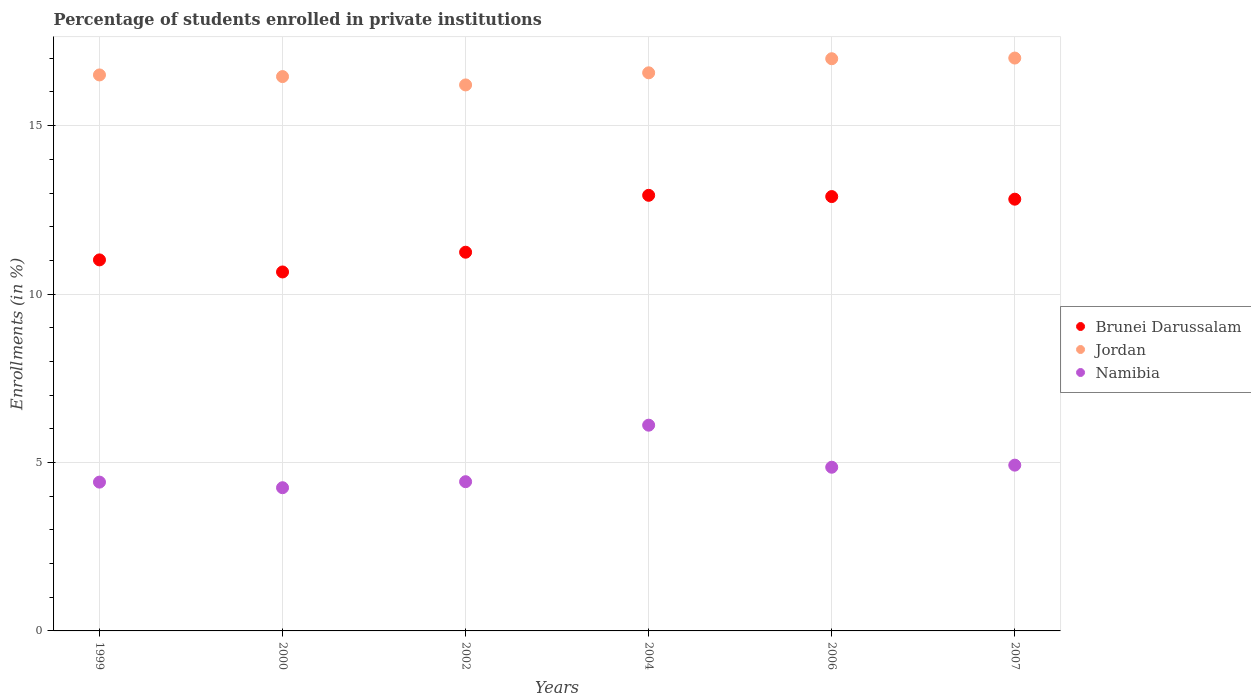How many different coloured dotlines are there?
Your answer should be compact. 3. Is the number of dotlines equal to the number of legend labels?
Ensure brevity in your answer.  Yes. What is the percentage of trained teachers in Jordan in 2004?
Offer a very short reply. 16.57. Across all years, what is the maximum percentage of trained teachers in Jordan?
Provide a succinct answer. 17.01. Across all years, what is the minimum percentage of trained teachers in Namibia?
Your response must be concise. 4.25. In which year was the percentage of trained teachers in Namibia maximum?
Your response must be concise. 2004. In which year was the percentage of trained teachers in Namibia minimum?
Keep it short and to the point. 2000. What is the total percentage of trained teachers in Jordan in the graph?
Offer a terse response. 99.73. What is the difference between the percentage of trained teachers in Jordan in 2000 and that in 2007?
Keep it short and to the point. -0.55. What is the difference between the percentage of trained teachers in Brunei Darussalam in 2004 and the percentage of trained teachers in Jordan in 2002?
Keep it short and to the point. -3.28. What is the average percentage of trained teachers in Namibia per year?
Make the answer very short. 4.83. In the year 2000, what is the difference between the percentage of trained teachers in Brunei Darussalam and percentage of trained teachers in Jordan?
Offer a very short reply. -5.8. What is the ratio of the percentage of trained teachers in Brunei Darussalam in 2006 to that in 2007?
Offer a terse response. 1.01. Is the difference between the percentage of trained teachers in Brunei Darussalam in 2002 and 2004 greater than the difference between the percentage of trained teachers in Jordan in 2002 and 2004?
Provide a succinct answer. No. What is the difference between the highest and the second highest percentage of trained teachers in Brunei Darussalam?
Your answer should be very brief. 0.04. What is the difference between the highest and the lowest percentage of trained teachers in Brunei Darussalam?
Provide a short and direct response. 2.28. In how many years, is the percentage of trained teachers in Jordan greater than the average percentage of trained teachers in Jordan taken over all years?
Ensure brevity in your answer.  2. Is it the case that in every year, the sum of the percentage of trained teachers in Namibia and percentage of trained teachers in Brunei Darussalam  is greater than the percentage of trained teachers in Jordan?
Keep it short and to the point. No. Does the percentage of trained teachers in Jordan monotonically increase over the years?
Offer a very short reply. No. Is the percentage of trained teachers in Brunei Darussalam strictly greater than the percentage of trained teachers in Namibia over the years?
Provide a succinct answer. Yes. Is the percentage of trained teachers in Jordan strictly less than the percentage of trained teachers in Brunei Darussalam over the years?
Offer a terse response. No. How many years are there in the graph?
Keep it short and to the point. 6. Are the values on the major ticks of Y-axis written in scientific E-notation?
Offer a very short reply. No. Does the graph contain any zero values?
Provide a succinct answer. No. How are the legend labels stacked?
Offer a terse response. Vertical. What is the title of the graph?
Offer a very short reply. Percentage of students enrolled in private institutions. What is the label or title of the X-axis?
Make the answer very short. Years. What is the label or title of the Y-axis?
Keep it short and to the point. Enrollments (in %). What is the Enrollments (in %) in Brunei Darussalam in 1999?
Your answer should be compact. 11.01. What is the Enrollments (in %) in Jordan in 1999?
Offer a terse response. 16.51. What is the Enrollments (in %) in Namibia in 1999?
Give a very brief answer. 4.42. What is the Enrollments (in %) of Brunei Darussalam in 2000?
Your response must be concise. 10.66. What is the Enrollments (in %) in Jordan in 2000?
Offer a very short reply. 16.46. What is the Enrollments (in %) in Namibia in 2000?
Ensure brevity in your answer.  4.25. What is the Enrollments (in %) of Brunei Darussalam in 2002?
Offer a terse response. 11.24. What is the Enrollments (in %) of Jordan in 2002?
Make the answer very short. 16.21. What is the Enrollments (in %) in Namibia in 2002?
Offer a very short reply. 4.43. What is the Enrollments (in %) in Brunei Darussalam in 2004?
Keep it short and to the point. 12.93. What is the Enrollments (in %) of Jordan in 2004?
Provide a short and direct response. 16.57. What is the Enrollments (in %) of Namibia in 2004?
Offer a very short reply. 6.11. What is the Enrollments (in %) in Brunei Darussalam in 2006?
Offer a very short reply. 12.89. What is the Enrollments (in %) of Jordan in 2006?
Provide a short and direct response. 16.99. What is the Enrollments (in %) of Namibia in 2006?
Provide a short and direct response. 4.86. What is the Enrollments (in %) in Brunei Darussalam in 2007?
Your response must be concise. 12.82. What is the Enrollments (in %) of Jordan in 2007?
Make the answer very short. 17.01. What is the Enrollments (in %) in Namibia in 2007?
Offer a terse response. 4.92. Across all years, what is the maximum Enrollments (in %) in Brunei Darussalam?
Offer a very short reply. 12.93. Across all years, what is the maximum Enrollments (in %) of Jordan?
Offer a very short reply. 17.01. Across all years, what is the maximum Enrollments (in %) in Namibia?
Keep it short and to the point. 6.11. Across all years, what is the minimum Enrollments (in %) in Brunei Darussalam?
Offer a very short reply. 10.66. Across all years, what is the minimum Enrollments (in %) of Jordan?
Your answer should be compact. 16.21. Across all years, what is the minimum Enrollments (in %) in Namibia?
Offer a terse response. 4.25. What is the total Enrollments (in %) of Brunei Darussalam in the graph?
Provide a short and direct response. 71.56. What is the total Enrollments (in %) of Jordan in the graph?
Provide a succinct answer. 99.73. What is the total Enrollments (in %) of Namibia in the graph?
Make the answer very short. 28.99. What is the difference between the Enrollments (in %) of Brunei Darussalam in 1999 and that in 2000?
Your answer should be compact. 0.36. What is the difference between the Enrollments (in %) in Jordan in 1999 and that in 2000?
Make the answer very short. 0.05. What is the difference between the Enrollments (in %) in Namibia in 1999 and that in 2000?
Provide a short and direct response. 0.17. What is the difference between the Enrollments (in %) in Brunei Darussalam in 1999 and that in 2002?
Give a very brief answer. -0.23. What is the difference between the Enrollments (in %) in Jordan in 1999 and that in 2002?
Your answer should be compact. 0.3. What is the difference between the Enrollments (in %) of Namibia in 1999 and that in 2002?
Ensure brevity in your answer.  -0.01. What is the difference between the Enrollments (in %) in Brunei Darussalam in 1999 and that in 2004?
Give a very brief answer. -1.92. What is the difference between the Enrollments (in %) of Jordan in 1999 and that in 2004?
Keep it short and to the point. -0.06. What is the difference between the Enrollments (in %) in Namibia in 1999 and that in 2004?
Provide a succinct answer. -1.69. What is the difference between the Enrollments (in %) in Brunei Darussalam in 1999 and that in 2006?
Ensure brevity in your answer.  -1.88. What is the difference between the Enrollments (in %) of Jordan in 1999 and that in 2006?
Your answer should be very brief. -0.48. What is the difference between the Enrollments (in %) of Namibia in 1999 and that in 2006?
Provide a short and direct response. -0.44. What is the difference between the Enrollments (in %) of Brunei Darussalam in 1999 and that in 2007?
Make the answer very short. -1.8. What is the difference between the Enrollments (in %) of Jordan in 1999 and that in 2007?
Your response must be concise. -0.5. What is the difference between the Enrollments (in %) in Namibia in 1999 and that in 2007?
Offer a very short reply. -0.5. What is the difference between the Enrollments (in %) of Brunei Darussalam in 2000 and that in 2002?
Offer a terse response. -0.59. What is the difference between the Enrollments (in %) in Jordan in 2000 and that in 2002?
Your answer should be very brief. 0.25. What is the difference between the Enrollments (in %) of Namibia in 2000 and that in 2002?
Make the answer very short. -0.18. What is the difference between the Enrollments (in %) in Brunei Darussalam in 2000 and that in 2004?
Offer a very short reply. -2.28. What is the difference between the Enrollments (in %) of Jordan in 2000 and that in 2004?
Ensure brevity in your answer.  -0.11. What is the difference between the Enrollments (in %) in Namibia in 2000 and that in 2004?
Make the answer very short. -1.86. What is the difference between the Enrollments (in %) of Brunei Darussalam in 2000 and that in 2006?
Your answer should be very brief. -2.24. What is the difference between the Enrollments (in %) in Jordan in 2000 and that in 2006?
Ensure brevity in your answer.  -0.53. What is the difference between the Enrollments (in %) of Namibia in 2000 and that in 2006?
Provide a succinct answer. -0.61. What is the difference between the Enrollments (in %) of Brunei Darussalam in 2000 and that in 2007?
Provide a short and direct response. -2.16. What is the difference between the Enrollments (in %) of Jordan in 2000 and that in 2007?
Ensure brevity in your answer.  -0.55. What is the difference between the Enrollments (in %) in Namibia in 2000 and that in 2007?
Ensure brevity in your answer.  -0.67. What is the difference between the Enrollments (in %) in Brunei Darussalam in 2002 and that in 2004?
Offer a terse response. -1.69. What is the difference between the Enrollments (in %) of Jordan in 2002 and that in 2004?
Your answer should be very brief. -0.36. What is the difference between the Enrollments (in %) of Namibia in 2002 and that in 2004?
Provide a succinct answer. -1.68. What is the difference between the Enrollments (in %) of Brunei Darussalam in 2002 and that in 2006?
Give a very brief answer. -1.65. What is the difference between the Enrollments (in %) of Jordan in 2002 and that in 2006?
Ensure brevity in your answer.  -0.78. What is the difference between the Enrollments (in %) of Namibia in 2002 and that in 2006?
Your answer should be compact. -0.43. What is the difference between the Enrollments (in %) in Brunei Darussalam in 2002 and that in 2007?
Offer a terse response. -1.57. What is the difference between the Enrollments (in %) of Jordan in 2002 and that in 2007?
Offer a terse response. -0.8. What is the difference between the Enrollments (in %) of Namibia in 2002 and that in 2007?
Offer a terse response. -0.49. What is the difference between the Enrollments (in %) of Brunei Darussalam in 2004 and that in 2006?
Your answer should be very brief. 0.04. What is the difference between the Enrollments (in %) of Jordan in 2004 and that in 2006?
Ensure brevity in your answer.  -0.42. What is the difference between the Enrollments (in %) of Namibia in 2004 and that in 2006?
Your answer should be compact. 1.25. What is the difference between the Enrollments (in %) of Brunei Darussalam in 2004 and that in 2007?
Offer a very short reply. 0.11. What is the difference between the Enrollments (in %) in Jordan in 2004 and that in 2007?
Your answer should be very brief. -0.44. What is the difference between the Enrollments (in %) of Namibia in 2004 and that in 2007?
Provide a short and direct response. 1.19. What is the difference between the Enrollments (in %) of Brunei Darussalam in 2006 and that in 2007?
Make the answer very short. 0.08. What is the difference between the Enrollments (in %) of Jordan in 2006 and that in 2007?
Your answer should be very brief. -0.02. What is the difference between the Enrollments (in %) of Namibia in 2006 and that in 2007?
Provide a succinct answer. -0.06. What is the difference between the Enrollments (in %) of Brunei Darussalam in 1999 and the Enrollments (in %) of Jordan in 2000?
Ensure brevity in your answer.  -5.44. What is the difference between the Enrollments (in %) in Brunei Darussalam in 1999 and the Enrollments (in %) in Namibia in 2000?
Give a very brief answer. 6.76. What is the difference between the Enrollments (in %) of Jordan in 1999 and the Enrollments (in %) of Namibia in 2000?
Your response must be concise. 12.25. What is the difference between the Enrollments (in %) of Brunei Darussalam in 1999 and the Enrollments (in %) of Jordan in 2002?
Ensure brevity in your answer.  -5.19. What is the difference between the Enrollments (in %) of Brunei Darussalam in 1999 and the Enrollments (in %) of Namibia in 2002?
Give a very brief answer. 6.58. What is the difference between the Enrollments (in %) of Jordan in 1999 and the Enrollments (in %) of Namibia in 2002?
Ensure brevity in your answer.  12.08. What is the difference between the Enrollments (in %) in Brunei Darussalam in 1999 and the Enrollments (in %) in Jordan in 2004?
Your answer should be compact. -5.55. What is the difference between the Enrollments (in %) in Brunei Darussalam in 1999 and the Enrollments (in %) in Namibia in 2004?
Keep it short and to the point. 4.91. What is the difference between the Enrollments (in %) of Jordan in 1999 and the Enrollments (in %) of Namibia in 2004?
Make the answer very short. 10.4. What is the difference between the Enrollments (in %) of Brunei Darussalam in 1999 and the Enrollments (in %) of Jordan in 2006?
Your response must be concise. -5.97. What is the difference between the Enrollments (in %) of Brunei Darussalam in 1999 and the Enrollments (in %) of Namibia in 2006?
Ensure brevity in your answer.  6.16. What is the difference between the Enrollments (in %) in Jordan in 1999 and the Enrollments (in %) in Namibia in 2006?
Keep it short and to the point. 11.65. What is the difference between the Enrollments (in %) of Brunei Darussalam in 1999 and the Enrollments (in %) of Jordan in 2007?
Offer a very short reply. -5.99. What is the difference between the Enrollments (in %) in Brunei Darussalam in 1999 and the Enrollments (in %) in Namibia in 2007?
Make the answer very short. 6.09. What is the difference between the Enrollments (in %) of Jordan in 1999 and the Enrollments (in %) of Namibia in 2007?
Make the answer very short. 11.58. What is the difference between the Enrollments (in %) of Brunei Darussalam in 2000 and the Enrollments (in %) of Jordan in 2002?
Your response must be concise. -5.55. What is the difference between the Enrollments (in %) in Brunei Darussalam in 2000 and the Enrollments (in %) in Namibia in 2002?
Provide a short and direct response. 6.23. What is the difference between the Enrollments (in %) of Jordan in 2000 and the Enrollments (in %) of Namibia in 2002?
Ensure brevity in your answer.  12.03. What is the difference between the Enrollments (in %) in Brunei Darussalam in 2000 and the Enrollments (in %) in Jordan in 2004?
Offer a terse response. -5.91. What is the difference between the Enrollments (in %) in Brunei Darussalam in 2000 and the Enrollments (in %) in Namibia in 2004?
Ensure brevity in your answer.  4.55. What is the difference between the Enrollments (in %) in Jordan in 2000 and the Enrollments (in %) in Namibia in 2004?
Your answer should be compact. 10.35. What is the difference between the Enrollments (in %) of Brunei Darussalam in 2000 and the Enrollments (in %) of Jordan in 2006?
Ensure brevity in your answer.  -6.33. What is the difference between the Enrollments (in %) of Brunei Darussalam in 2000 and the Enrollments (in %) of Namibia in 2006?
Your answer should be compact. 5.8. What is the difference between the Enrollments (in %) of Jordan in 2000 and the Enrollments (in %) of Namibia in 2006?
Your answer should be very brief. 11.6. What is the difference between the Enrollments (in %) in Brunei Darussalam in 2000 and the Enrollments (in %) in Jordan in 2007?
Your response must be concise. -6.35. What is the difference between the Enrollments (in %) in Brunei Darussalam in 2000 and the Enrollments (in %) in Namibia in 2007?
Offer a very short reply. 5.73. What is the difference between the Enrollments (in %) in Jordan in 2000 and the Enrollments (in %) in Namibia in 2007?
Your answer should be compact. 11.54. What is the difference between the Enrollments (in %) in Brunei Darussalam in 2002 and the Enrollments (in %) in Jordan in 2004?
Give a very brief answer. -5.33. What is the difference between the Enrollments (in %) in Brunei Darussalam in 2002 and the Enrollments (in %) in Namibia in 2004?
Provide a short and direct response. 5.13. What is the difference between the Enrollments (in %) of Jordan in 2002 and the Enrollments (in %) of Namibia in 2004?
Your response must be concise. 10.1. What is the difference between the Enrollments (in %) of Brunei Darussalam in 2002 and the Enrollments (in %) of Jordan in 2006?
Offer a very short reply. -5.74. What is the difference between the Enrollments (in %) in Brunei Darussalam in 2002 and the Enrollments (in %) in Namibia in 2006?
Provide a short and direct response. 6.38. What is the difference between the Enrollments (in %) of Jordan in 2002 and the Enrollments (in %) of Namibia in 2006?
Provide a succinct answer. 11.35. What is the difference between the Enrollments (in %) of Brunei Darussalam in 2002 and the Enrollments (in %) of Jordan in 2007?
Ensure brevity in your answer.  -5.76. What is the difference between the Enrollments (in %) of Brunei Darussalam in 2002 and the Enrollments (in %) of Namibia in 2007?
Ensure brevity in your answer.  6.32. What is the difference between the Enrollments (in %) of Jordan in 2002 and the Enrollments (in %) of Namibia in 2007?
Provide a short and direct response. 11.29. What is the difference between the Enrollments (in %) in Brunei Darussalam in 2004 and the Enrollments (in %) in Jordan in 2006?
Offer a terse response. -4.05. What is the difference between the Enrollments (in %) in Brunei Darussalam in 2004 and the Enrollments (in %) in Namibia in 2006?
Offer a very short reply. 8.07. What is the difference between the Enrollments (in %) of Jordan in 2004 and the Enrollments (in %) of Namibia in 2006?
Give a very brief answer. 11.71. What is the difference between the Enrollments (in %) of Brunei Darussalam in 2004 and the Enrollments (in %) of Jordan in 2007?
Keep it short and to the point. -4.07. What is the difference between the Enrollments (in %) in Brunei Darussalam in 2004 and the Enrollments (in %) in Namibia in 2007?
Give a very brief answer. 8.01. What is the difference between the Enrollments (in %) of Jordan in 2004 and the Enrollments (in %) of Namibia in 2007?
Offer a terse response. 11.65. What is the difference between the Enrollments (in %) of Brunei Darussalam in 2006 and the Enrollments (in %) of Jordan in 2007?
Provide a short and direct response. -4.11. What is the difference between the Enrollments (in %) in Brunei Darussalam in 2006 and the Enrollments (in %) in Namibia in 2007?
Your answer should be compact. 7.97. What is the difference between the Enrollments (in %) in Jordan in 2006 and the Enrollments (in %) in Namibia in 2007?
Make the answer very short. 12.07. What is the average Enrollments (in %) of Brunei Darussalam per year?
Your answer should be very brief. 11.93. What is the average Enrollments (in %) of Jordan per year?
Your answer should be very brief. 16.62. What is the average Enrollments (in %) of Namibia per year?
Your answer should be compact. 4.83. In the year 1999, what is the difference between the Enrollments (in %) of Brunei Darussalam and Enrollments (in %) of Jordan?
Ensure brevity in your answer.  -5.49. In the year 1999, what is the difference between the Enrollments (in %) of Brunei Darussalam and Enrollments (in %) of Namibia?
Offer a terse response. 6.6. In the year 1999, what is the difference between the Enrollments (in %) in Jordan and Enrollments (in %) in Namibia?
Your answer should be very brief. 12.09. In the year 2000, what is the difference between the Enrollments (in %) of Brunei Darussalam and Enrollments (in %) of Jordan?
Your answer should be compact. -5.8. In the year 2000, what is the difference between the Enrollments (in %) of Brunei Darussalam and Enrollments (in %) of Namibia?
Offer a very short reply. 6.41. In the year 2000, what is the difference between the Enrollments (in %) in Jordan and Enrollments (in %) in Namibia?
Make the answer very short. 12.21. In the year 2002, what is the difference between the Enrollments (in %) in Brunei Darussalam and Enrollments (in %) in Jordan?
Offer a very short reply. -4.97. In the year 2002, what is the difference between the Enrollments (in %) in Brunei Darussalam and Enrollments (in %) in Namibia?
Your answer should be very brief. 6.81. In the year 2002, what is the difference between the Enrollments (in %) of Jordan and Enrollments (in %) of Namibia?
Make the answer very short. 11.78. In the year 2004, what is the difference between the Enrollments (in %) of Brunei Darussalam and Enrollments (in %) of Jordan?
Offer a very short reply. -3.64. In the year 2004, what is the difference between the Enrollments (in %) of Brunei Darussalam and Enrollments (in %) of Namibia?
Provide a short and direct response. 6.82. In the year 2004, what is the difference between the Enrollments (in %) of Jordan and Enrollments (in %) of Namibia?
Your response must be concise. 10.46. In the year 2006, what is the difference between the Enrollments (in %) in Brunei Darussalam and Enrollments (in %) in Jordan?
Your answer should be very brief. -4.09. In the year 2006, what is the difference between the Enrollments (in %) in Brunei Darussalam and Enrollments (in %) in Namibia?
Your answer should be very brief. 8.04. In the year 2006, what is the difference between the Enrollments (in %) in Jordan and Enrollments (in %) in Namibia?
Your response must be concise. 12.13. In the year 2007, what is the difference between the Enrollments (in %) in Brunei Darussalam and Enrollments (in %) in Jordan?
Your answer should be very brief. -4.19. In the year 2007, what is the difference between the Enrollments (in %) of Brunei Darussalam and Enrollments (in %) of Namibia?
Your response must be concise. 7.9. In the year 2007, what is the difference between the Enrollments (in %) of Jordan and Enrollments (in %) of Namibia?
Your response must be concise. 12.09. What is the ratio of the Enrollments (in %) in Brunei Darussalam in 1999 to that in 2000?
Offer a very short reply. 1.03. What is the ratio of the Enrollments (in %) of Jordan in 1999 to that in 2000?
Your answer should be very brief. 1. What is the ratio of the Enrollments (in %) in Namibia in 1999 to that in 2000?
Give a very brief answer. 1.04. What is the ratio of the Enrollments (in %) of Brunei Darussalam in 1999 to that in 2002?
Your response must be concise. 0.98. What is the ratio of the Enrollments (in %) in Jordan in 1999 to that in 2002?
Keep it short and to the point. 1.02. What is the ratio of the Enrollments (in %) of Brunei Darussalam in 1999 to that in 2004?
Ensure brevity in your answer.  0.85. What is the ratio of the Enrollments (in %) of Namibia in 1999 to that in 2004?
Make the answer very short. 0.72. What is the ratio of the Enrollments (in %) of Brunei Darussalam in 1999 to that in 2006?
Make the answer very short. 0.85. What is the ratio of the Enrollments (in %) in Jordan in 1999 to that in 2006?
Provide a succinct answer. 0.97. What is the ratio of the Enrollments (in %) in Namibia in 1999 to that in 2006?
Your answer should be compact. 0.91. What is the ratio of the Enrollments (in %) in Brunei Darussalam in 1999 to that in 2007?
Ensure brevity in your answer.  0.86. What is the ratio of the Enrollments (in %) of Jordan in 1999 to that in 2007?
Provide a short and direct response. 0.97. What is the ratio of the Enrollments (in %) of Namibia in 1999 to that in 2007?
Your answer should be very brief. 0.9. What is the ratio of the Enrollments (in %) in Brunei Darussalam in 2000 to that in 2002?
Your answer should be very brief. 0.95. What is the ratio of the Enrollments (in %) of Jordan in 2000 to that in 2002?
Your answer should be very brief. 1.02. What is the ratio of the Enrollments (in %) of Namibia in 2000 to that in 2002?
Give a very brief answer. 0.96. What is the ratio of the Enrollments (in %) of Brunei Darussalam in 2000 to that in 2004?
Give a very brief answer. 0.82. What is the ratio of the Enrollments (in %) of Jordan in 2000 to that in 2004?
Offer a terse response. 0.99. What is the ratio of the Enrollments (in %) of Namibia in 2000 to that in 2004?
Give a very brief answer. 0.7. What is the ratio of the Enrollments (in %) in Brunei Darussalam in 2000 to that in 2006?
Offer a terse response. 0.83. What is the ratio of the Enrollments (in %) of Jordan in 2000 to that in 2006?
Provide a succinct answer. 0.97. What is the ratio of the Enrollments (in %) in Namibia in 2000 to that in 2006?
Keep it short and to the point. 0.87. What is the ratio of the Enrollments (in %) of Brunei Darussalam in 2000 to that in 2007?
Provide a short and direct response. 0.83. What is the ratio of the Enrollments (in %) of Namibia in 2000 to that in 2007?
Offer a terse response. 0.86. What is the ratio of the Enrollments (in %) in Brunei Darussalam in 2002 to that in 2004?
Offer a very short reply. 0.87. What is the ratio of the Enrollments (in %) in Jordan in 2002 to that in 2004?
Offer a very short reply. 0.98. What is the ratio of the Enrollments (in %) of Namibia in 2002 to that in 2004?
Give a very brief answer. 0.73. What is the ratio of the Enrollments (in %) of Brunei Darussalam in 2002 to that in 2006?
Your response must be concise. 0.87. What is the ratio of the Enrollments (in %) of Jordan in 2002 to that in 2006?
Your response must be concise. 0.95. What is the ratio of the Enrollments (in %) in Namibia in 2002 to that in 2006?
Provide a succinct answer. 0.91. What is the ratio of the Enrollments (in %) in Brunei Darussalam in 2002 to that in 2007?
Your answer should be very brief. 0.88. What is the ratio of the Enrollments (in %) of Jordan in 2002 to that in 2007?
Make the answer very short. 0.95. What is the ratio of the Enrollments (in %) of Namibia in 2002 to that in 2007?
Your answer should be compact. 0.9. What is the ratio of the Enrollments (in %) of Jordan in 2004 to that in 2006?
Your answer should be very brief. 0.98. What is the ratio of the Enrollments (in %) in Namibia in 2004 to that in 2006?
Your response must be concise. 1.26. What is the ratio of the Enrollments (in %) of Brunei Darussalam in 2004 to that in 2007?
Offer a terse response. 1.01. What is the ratio of the Enrollments (in %) of Jordan in 2004 to that in 2007?
Your response must be concise. 0.97. What is the ratio of the Enrollments (in %) in Namibia in 2004 to that in 2007?
Ensure brevity in your answer.  1.24. What is the ratio of the Enrollments (in %) of Brunei Darussalam in 2006 to that in 2007?
Provide a succinct answer. 1.01. What is the ratio of the Enrollments (in %) in Namibia in 2006 to that in 2007?
Keep it short and to the point. 0.99. What is the difference between the highest and the second highest Enrollments (in %) in Brunei Darussalam?
Provide a short and direct response. 0.04. What is the difference between the highest and the second highest Enrollments (in %) of Jordan?
Your response must be concise. 0.02. What is the difference between the highest and the second highest Enrollments (in %) of Namibia?
Your answer should be compact. 1.19. What is the difference between the highest and the lowest Enrollments (in %) in Brunei Darussalam?
Give a very brief answer. 2.28. What is the difference between the highest and the lowest Enrollments (in %) in Jordan?
Your response must be concise. 0.8. What is the difference between the highest and the lowest Enrollments (in %) of Namibia?
Keep it short and to the point. 1.86. 